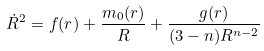Convert formula to latex. <formula><loc_0><loc_0><loc_500><loc_500>\dot { R } ^ { 2 } = f ( r ) + \frac { m _ { 0 } ( r ) } { R } + \frac { g ( r ) } { ( 3 - n ) R ^ { n - 2 } }</formula> 